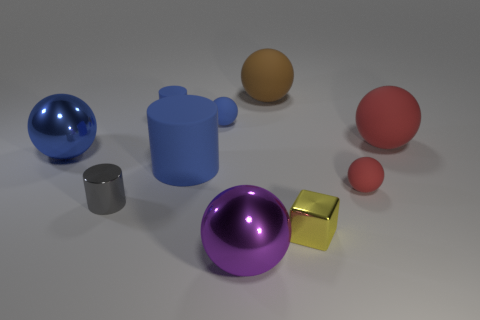Subtract all purple balls. How many balls are left? 5 Subtract all purple balls. How many balls are left? 5 Subtract all cylinders. How many objects are left? 7 Add 5 small gray metallic objects. How many small gray metallic objects are left? 6 Add 2 blue spheres. How many blue spheres exist? 4 Subtract 0 brown cylinders. How many objects are left? 10 Subtract 3 balls. How many balls are left? 3 Subtract all cyan blocks. Subtract all green spheres. How many blocks are left? 1 Subtract all brown blocks. How many brown balls are left? 1 Subtract all balls. Subtract all big gray rubber cylinders. How many objects are left? 4 